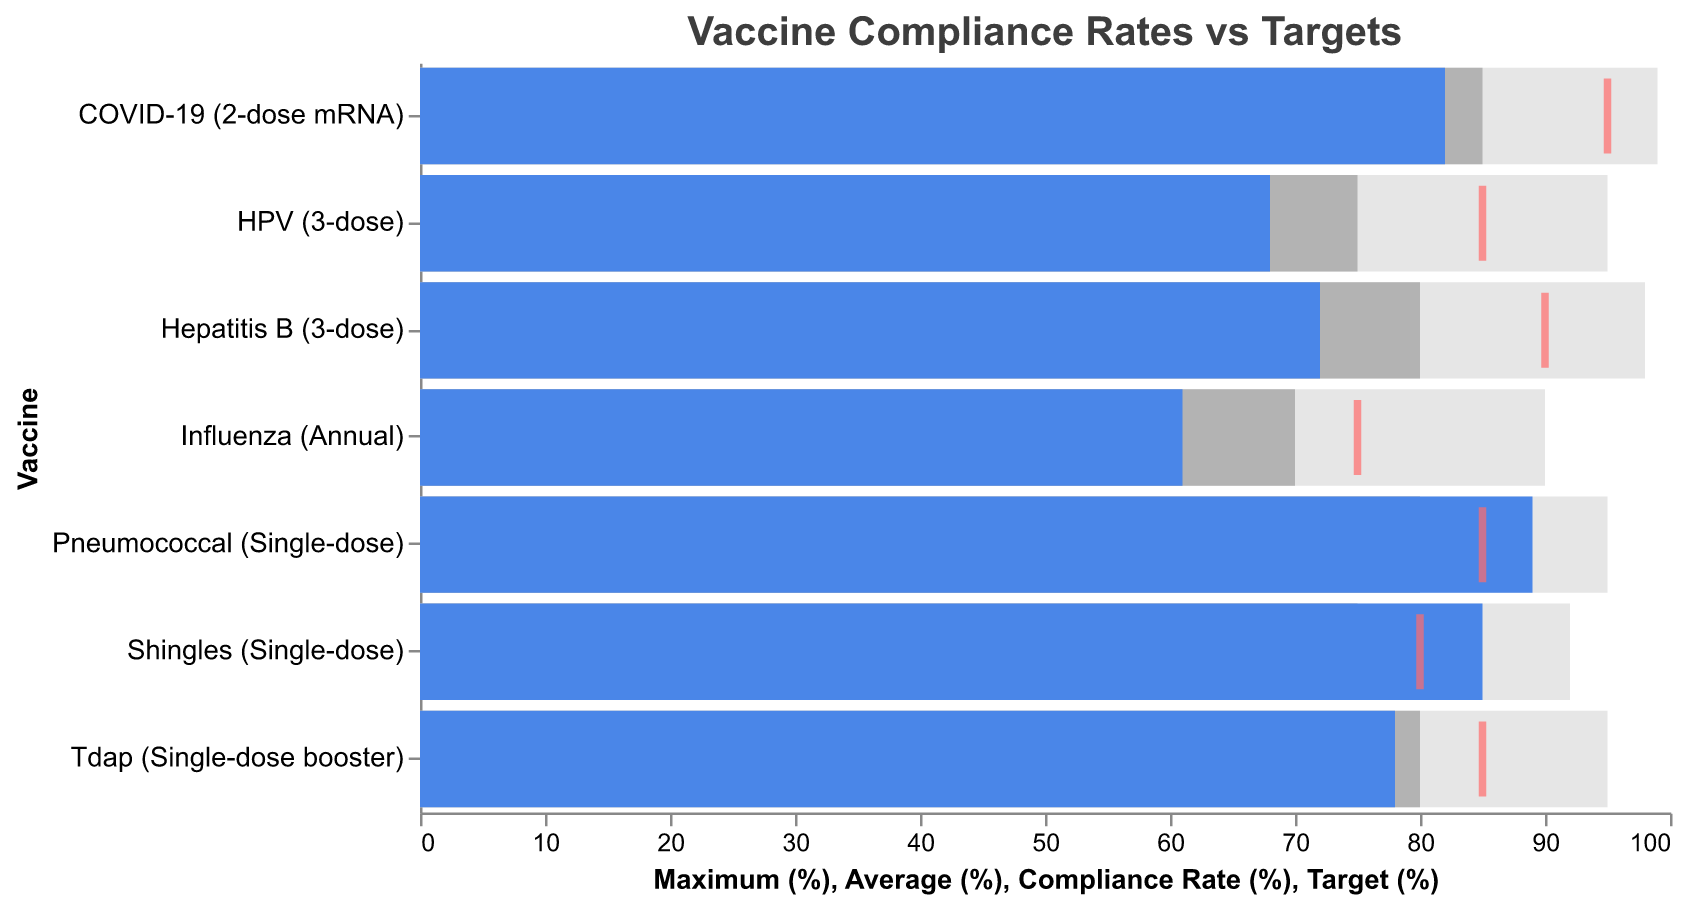what is the Compliance Rate for HPV (3-dose) vaccine? The Compliance Rate value for HPV (3-dose) is located under the "Compliance Rate (%)" column and reads 68%.
Answer: 68% Which vaccine has the highest Maximum (%)? The Maximum (%) value for each vaccine is shown in the figure. The highest value is 99%, associated with the COVID-19 (2-dose mRNA) vaccine.
Answer: COVID-19 (2-dose mRNA) Does the Pneumococcal (Single-dose) vaccine exceed its Target (%)? The compliance rate of Pneumococcal (Single-dose) is 89%, and its target is 85%. Since 89% > 85%, it exceeds its target.
Answer: Yes What is the difference between the Compliance Rate and the Target (%) for Influenza (Annual)? The Compliance Rate for Influenza (Annual) is 61%, and its Target (%) is 75%. The difference is 75% - 61% = 14%.
Answer: 14% Between HPV (3-dose) and Hepatitis B (3-dose), which has a higher Average (%)? The Average (%) for HPV (3-dose) is 75%, and for Hepatitis B, it is 80%. Since 80% > 75%, Hepatitis B (3-dose) has a higher average.
Answer: Hepatitis B (3-dose) How many vaccines fall below their Target (%)? By examining the figure and comparing the Compliance Rate to the Target (%), HPV (3-dose), Hepatitis B (3-dose), Influenza (Annual), and Tdap (Single-dose booster) fall below their targets. There are 4 such vaccines.
Answer: 4 Which single-dose vaccine has the highest Compliance Rate? Among the single-dose vaccines, Pneumococcal (Single-dose) has the highest Compliance Rate of 89%.
Answer: Pneumococcal (Single-dose) Compare the compliance rate of COVID-19 (2-dose mRNA) and Pneumococcal (Single-dose). Which is higher and by how much? The Compliance Rate for COVID-19 (2-dose mRNA) is 82%, and for Pneumococcal (Single-dose), it is 89%. The difference is 89% - 82% = 7%. Pneumococcal is higher.
Answer: 7% Which vaccine has the closest Compliance Rate to its Average (%)? The compliance rate and average values are HPV (68% vs 75%), Hepatitis B (72% vs 80%), COVID-19 (82% vs 85%), Influenza (61% vs 70%), Pneumococcal (89% vs 80%), Shingles (85% vs 75%), and Tdap (78% vs 80%). The closest pair is the COVID-19 with a difference of 3%.
Answer: COVID-19 (2-dose mRNA) What is the Average (%) across all vaccines? To find the overall average, sum the Average (%) values and divide by the number of vaccines. (75 + 80 + 85 + 70 + 80 + 75 + 80) / 7 = 545 / 7 = 77.857%.
Answer: 77.857% 